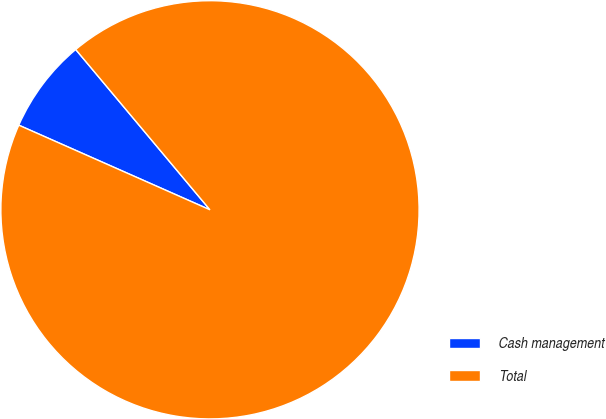Convert chart. <chart><loc_0><loc_0><loc_500><loc_500><pie_chart><fcel>Cash management<fcel>Total<nl><fcel>7.27%<fcel>92.73%<nl></chart> 